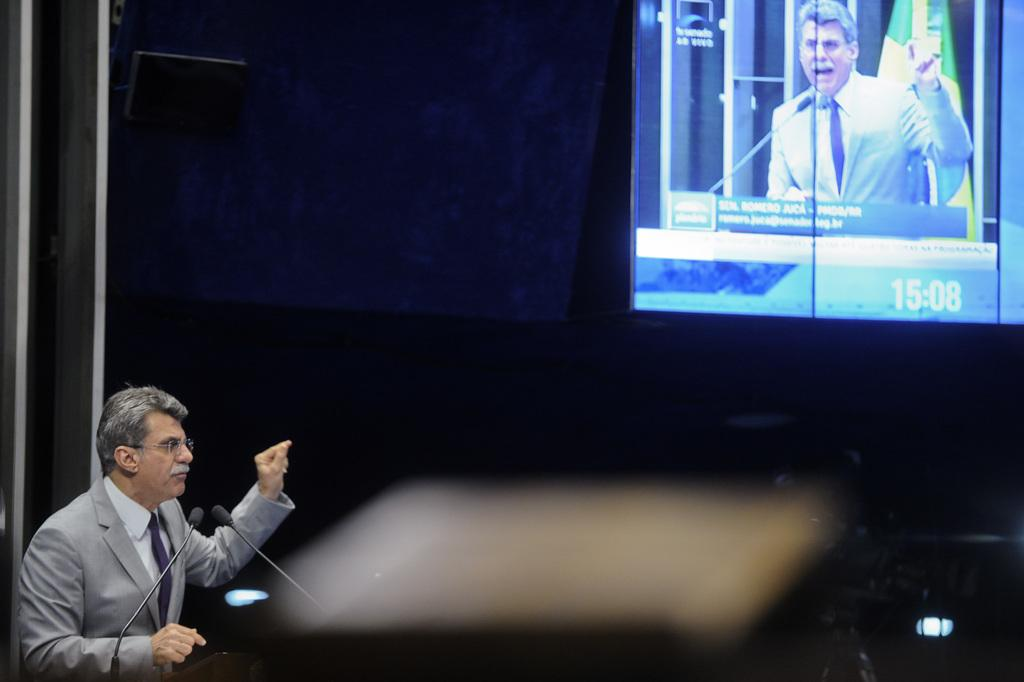<image>
Write a terse but informative summary of the picture. a clock that says 15:08 on the screen and a man in a suit 